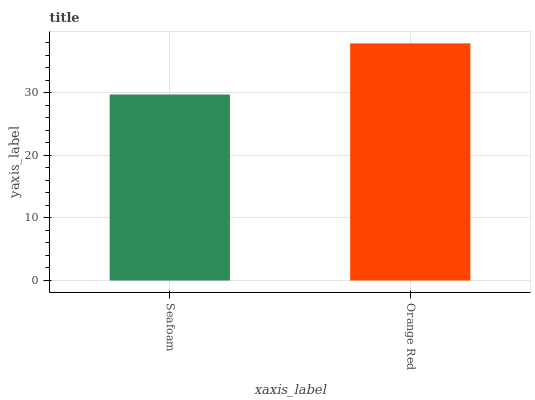Is Orange Red the minimum?
Answer yes or no. No. Is Orange Red greater than Seafoam?
Answer yes or no. Yes. Is Seafoam less than Orange Red?
Answer yes or no. Yes. Is Seafoam greater than Orange Red?
Answer yes or no. No. Is Orange Red less than Seafoam?
Answer yes or no. No. Is Orange Red the high median?
Answer yes or no. Yes. Is Seafoam the low median?
Answer yes or no. Yes. Is Seafoam the high median?
Answer yes or no. No. Is Orange Red the low median?
Answer yes or no. No. 